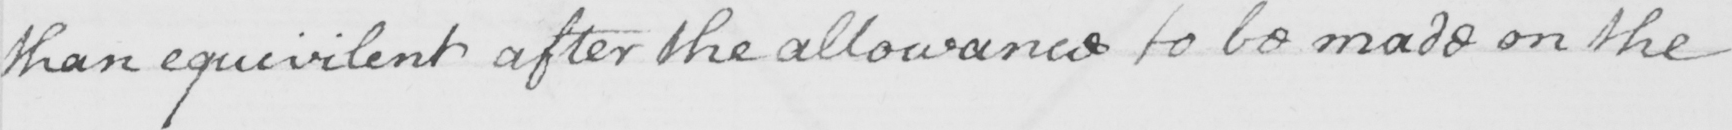Please transcribe the handwritten text in this image. than equivilent after the allowance to be made on the 